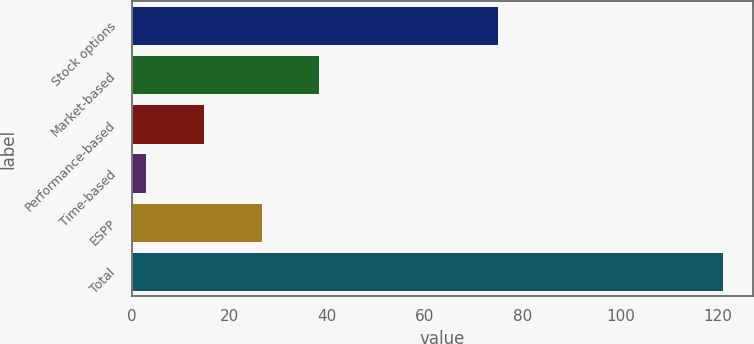Convert chart. <chart><loc_0><loc_0><loc_500><loc_500><bar_chart><fcel>Stock options<fcel>Market-based<fcel>Performance-based<fcel>Time-based<fcel>ESPP<fcel>Total<nl><fcel>75<fcel>38.4<fcel>14.8<fcel>3<fcel>26.6<fcel>121<nl></chart> 